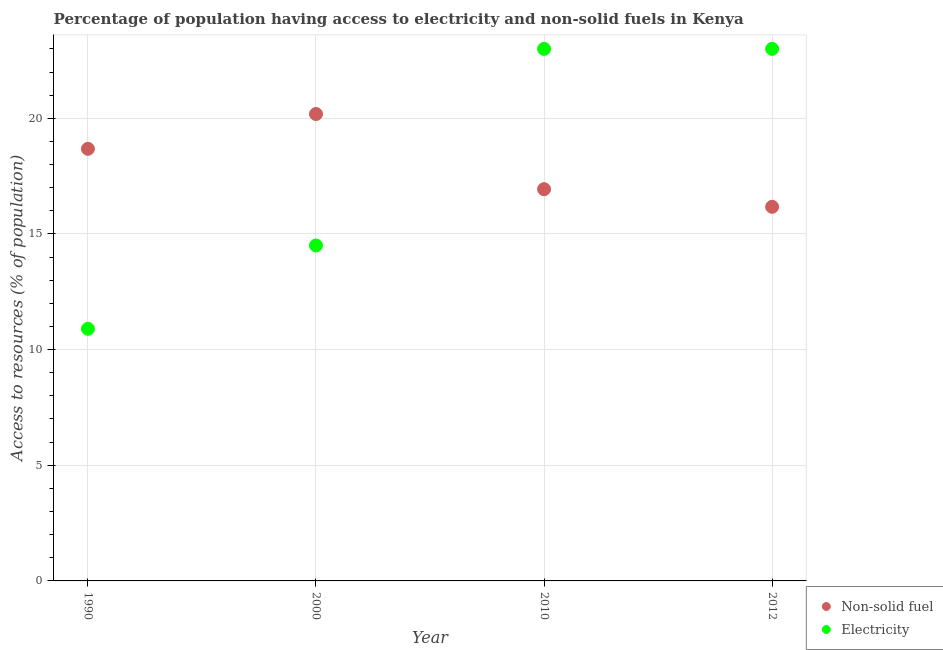How many different coloured dotlines are there?
Make the answer very short. 2. What is the percentage of population having access to electricity in 2010?
Provide a succinct answer. 23. Across all years, what is the maximum percentage of population having access to non-solid fuel?
Your response must be concise. 20.18. In which year was the percentage of population having access to non-solid fuel minimum?
Keep it short and to the point. 2012. What is the total percentage of population having access to non-solid fuel in the graph?
Ensure brevity in your answer.  71.97. What is the difference between the percentage of population having access to electricity in 2000 and that in 2012?
Your answer should be compact. -8.5. What is the difference between the percentage of population having access to non-solid fuel in 2010 and the percentage of population having access to electricity in 2000?
Keep it short and to the point. 2.43. What is the average percentage of population having access to non-solid fuel per year?
Your answer should be compact. 17.99. In the year 2012, what is the difference between the percentage of population having access to non-solid fuel and percentage of population having access to electricity?
Your answer should be compact. -6.83. What is the ratio of the percentage of population having access to electricity in 2000 to that in 2010?
Ensure brevity in your answer.  0.63. Is the difference between the percentage of population having access to electricity in 1990 and 2010 greater than the difference between the percentage of population having access to non-solid fuel in 1990 and 2010?
Offer a terse response. No. What is the difference between the highest and the lowest percentage of population having access to non-solid fuel?
Give a very brief answer. 4.01. Does the percentage of population having access to non-solid fuel monotonically increase over the years?
Your response must be concise. No. Is the percentage of population having access to non-solid fuel strictly greater than the percentage of population having access to electricity over the years?
Your response must be concise. No. Does the graph contain any zero values?
Make the answer very short. No. Does the graph contain grids?
Provide a short and direct response. Yes. Where does the legend appear in the graph?
Provide a short and direct response. Bottom right. How many legend labels are there?
Your response must be concise. 2. What is the title of the graph?
Ensure brevity in your answer.  Percentage of population having access to electricity and non-solid fuels in Kenya. What is the label or title of the Y-axis?
Your response must be concise. Access to resources (% of population). What is the Access to resources (% of population) in Non-solid fuel in 1990?
Your answer should be very brief. 18.68. What is the Access to resources (% of population) in Electricity in 1990?
Offer a very short reply. 10.9. What is the Access to resources (% of population) of Non-solid fuel in 2000?
Offer a terse response. 20.18. What is the Access to resources (% of population) in Non-solid fuel in 2010?
Make the answer very short. 16.93. What is the Access to resources (% of population) in Non-solid fuel in 2012?
Your response must be concise. 16.17. Across all years, what is the maximum Access to resources (% of population) in Non-solid fuel?
Provide a short and direct response. 20.18. Across all years, what is the maximum Access to resources (% of population) in Electricity?
Ensure brevity in your answer.  23. Across all years, what is the minimum Access to resources (% of population) in Non-solid fuel?
Your answer should be compact. 16.17. What is the total Access to resources (% of population) in Non-solid fuel in the graph?
Your response must be concise. 71.97. What is the total Access to resources (% of population) in Electricity in the graph?
Provide a short and direct response. 71.4. What is the difference between the Access to resources (% of population) in Non-solid fuel in 1990 and that in 2000?
Give a very brief answer. -1.51. What is the difference between the Access to resources (% of population) of Non-solid fuel in 1990 and that in 2010?
Give a very brief answer. 1.74. What is the difference between the Access to resources (% of population) in Electricity in 1990 and that in 2010?
Keep it short and to the point. -12.1. What is the difference between the Access to resources (% of population) of Non-solid fuel in 1990 and that in 2012?
Give a very brief answer. 2.51. What is the difference between the Access to resources (% of population) of Electricity in 1990 and that in 2012?
Your answer should be very brief. -12.1. What is the difference between the Access to resources (% of population) of Non-solid fuel in 2000 and that in 2010?
Your answer should be compact. 3.25. What is the difference between the Access to resources (% of population) of Electricity in 2000 and that in 2010?
Give a very brief answer. -8.5. What is the difference between the Access to resources (% of population) in Non-solid fuel in 2000 and that in 2012?
Offer a very short reply. 4.01. What is the difference between the Access to resources (% of population) of Non-solid fuel in 2010 and that in 2012?
Make the answer very short. 0.76. What is the difference between the Access to resources (% of population) in Electricity in 2010 and that in 2012?
Your answer should be very brief. 0. What is the difference between the Access to resources (% of population) in Non-solid fuel in 1990 and the Access to resources (% of population) in Electricity in 2000?
Your answer should be very brief. 4.18. What is the difference between the Access to resources (% of population) in Non-solid fuel in 1990 and the Access to resources (% of population) in Electricity in 2010?
Your answer should be very brief. -4.32. What is the difference between the Access to resources (% of population) of Non-solid fuel in 1990 and the Access to resources (% of population) of Electricity in 2012?
Make the answer very short. -4.32. What is the difference between the Access to resources (% of population) in Non-solid fuel in 2000 and the Access to resources (% of population) in Electricity in 2010?
Your answer should be very brief. -2.82. What is the difference between the Access to resources (% of population) in Non-solid fuel in 2000 and the Access to resources (% of population) in Electricity in 2012?
Ensure brevity in your answer.  -2.82. What is the difference between the Access to resources (% of population) of Non-solid fuel in 2010 and the Access to resources (% of population) of Electricity in 2012?
Make the answer very short. -6.07. What is the average Access to resources (% of population) of Non-solid fuel per year?
Offer a very short reply. 17.99. What is the average Access to resources (% of population) in Electricity per year?
Keep it short and to the point. 17.85. In the year 1990, what is the difference between the Access to resources (% of population) in Non-solid fuel and Access to resources (% of population) in Electricity?
Offer a terse response. 7.78. In the year 2000, what is the difference between the Access to resources (% of population) of Non-solid fuel and Access to resources (% of population) of Electricity?
Your answer should be very brief. 5.68. In the year 2010, what is the difference between the Access to resources (% of population) of Non-solid fuel and Access to resources (% of population) of Electricity?
Your answer should be very brief. -6.07. In the year 2012, what is the difference between the Access to resources (% of population) in Non-solid fuel and Access to resources (% of population) in Electricity?
Keep it short and to the point. -6.83. What is the ratio of the Access to resources (% of population) in Non-solid fuel in 1990 to that in 2000?
Offer a terse response. 0.93. What is the ratio of the Access to resources (% of population) of Electricity in 1990 to that in 2000?
Provide a succinct answer. 0.75. What is the ratio of the Access to resources (% of population) of Non-solid fuel in 1990 to that in 2010?
Your response must be concise. 1.1. What is the ratio of the Access to resources (% of population) in Electricity in 1990 to that in 2010?
Your response must be concise. 0.47. What is the ratio of the Access to resources (% of population) in Non-solid fuel in 1990 to that in 2012?
Keep it short and to the point. 1.16. What is the ratio of the Access to resources (% of population) of Electricity in 1990 to that in 2012?
Ensure brevity in your answer.  0.47. What is the ratio of the Access to resources (% of population) in Non-solid fuel in 2000 to that in 2010?
Your response must be concise. 1.19. What is the ratio of the Access to resources (% of population) of Electricity in 2000 to that in 2010?
Keep it short and to the point. 0.63. What is the ratio of the Access to resources (% of population) of Non-solid fuel in 2000 to that in 2012?
Provide a short and direct response. 1.25. What is the ratio of the Access to resources (% of population) in Electricity in 2000 to that in 2012?
Provide a succinct answer. 0.63. What is the ratio of the Access to resources (% of population) in Non-solid fuel in 2010 to that in 2012?
Make the answer very short. 1.05. What is the difference between the highest and the second highest Access to resources (% of population) of Non-solid fuel?
Offer a very short reply. 1.51. What is the difference between the highest and the lowest Access to resources (% of population) in Non-solid fuel?
Ensure brevity in your answer.  4.01. What is the difference between the highest and the lowest Access to resources (% of population) of Electricity?
Offer a terse response. 12.1. 